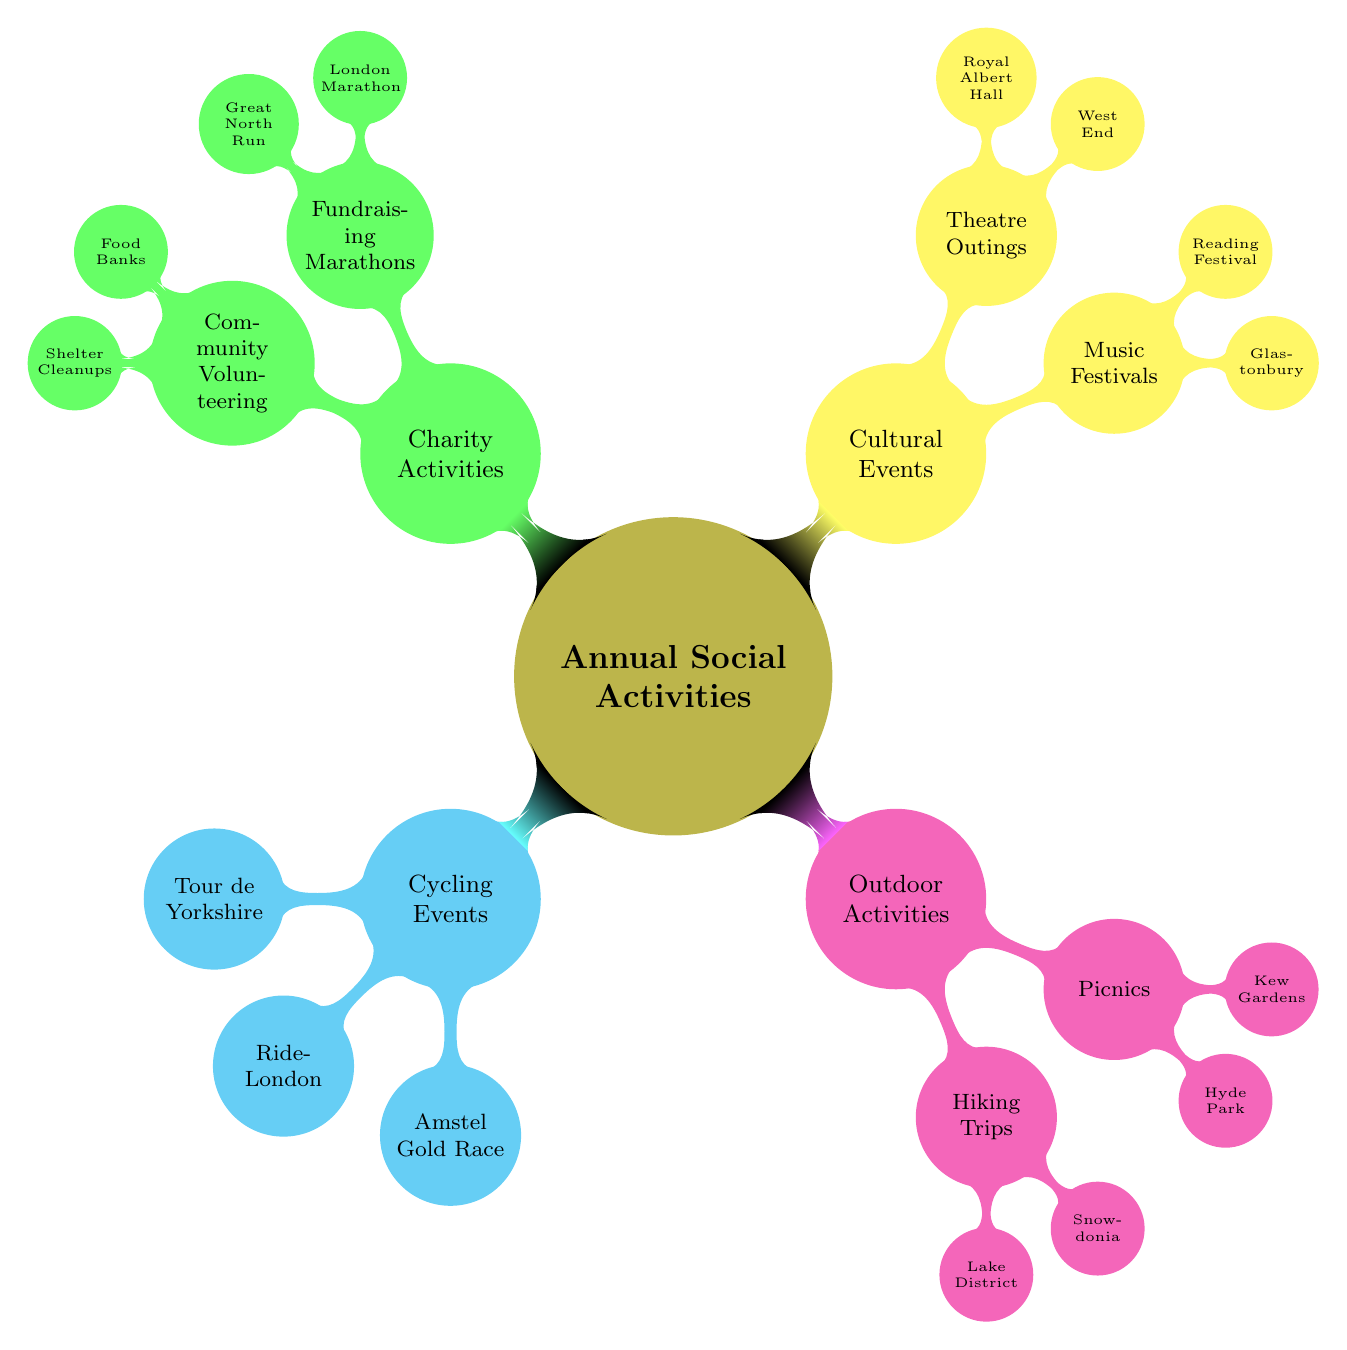What are the two main categories of activities in the mind map? The mind map contains four main categories: Cycling Events, Outdoor Activities, Cultural Events, and Charity Activities. The two main categories here are those two specific types of activities.
Answer: Cycling Events, Outdoor Activities How many cycling events are listed? In the Cycling Events node, there are three sub-nodes: Tour de Yorkshire, RideLondon, and Amstel Gold Race. Therefore, the total count directly corresponds to the number of these events under the Cycling Events category.
Answer: 3 What is one activity you can do in the Lake District? The Lake District is specified as a Hiking Trip under the Outdoor Activities category. It is a type of outdoor activity focused specifically on hiking, with no further subdivision under its node.
Answer: Hiking Trip Which cultural event has sub-events related to music? The Cultural Events node has a sub-node titled Music Festivals, which includes Glastonbury and Reading Festival as specific events. Hence, the broader cultural event in question is related to music festivals.
Answer: Music Festivals How many types of charity activities are listed? The Charity Activities node lists two types of activities: Fundraising Marathons and Community Volunteering identified as distinct categories. Thus, the count is based on these two categories directly listed in the charity section.
Answer: 2 Which park is mentioned as a location for picnics? Within the Picnics node of Outdoor Activities, Kew Gardens is listed as one of the specific locations for this type of social activity. Thus, identifying the correct park can be referenced based on the specific mention in the diagram.
Answer: Kew Gardens What is the relationship between Theatre Outings and Cultural Events? Theatre Outings is a sub-node within the Cultural Events category, signifying that Theatre Outings are a type of cultural event according to the structure of the mind map. Hence, the relationship denotes a sub-category under the broader cultural category.
Answer: Sub-category How many nodes directly represent cultural activities? Within the Cultural Events category, there are two listed nodes (Music Festivals and Theatre Outings), both of which represent distinct cultural activities. Therefore, counting these distinct categories gives the total number of cultural activity representations.
Answer: 2 